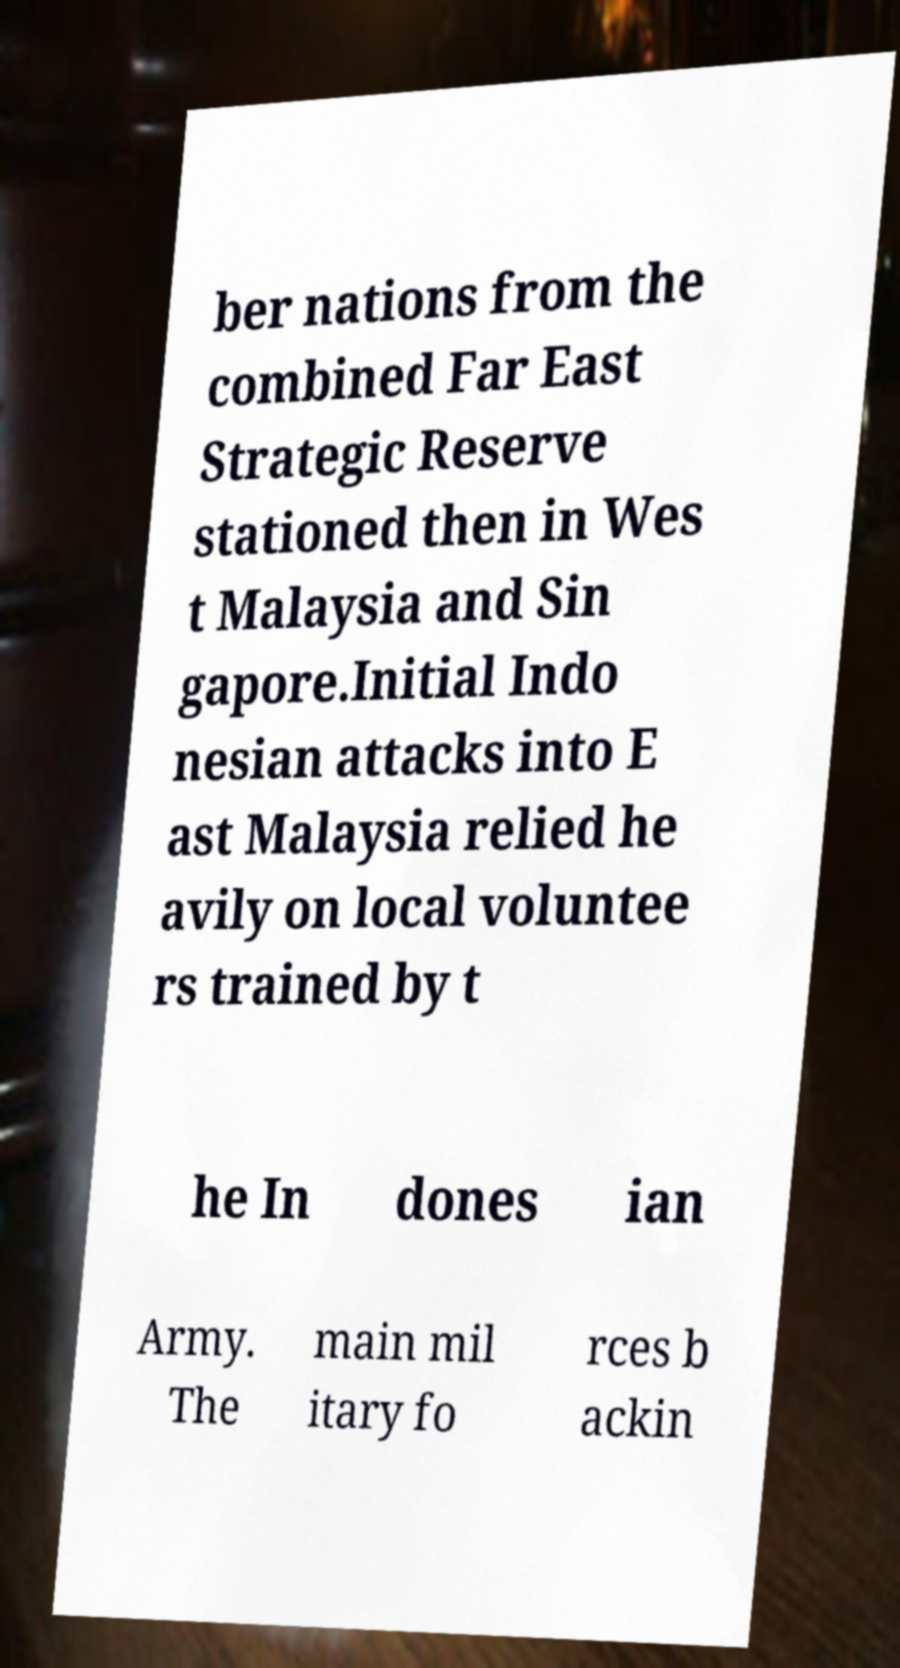For documentation purposes, I need the text within this image transcribed. Could you provide that? ber nations from the combined Far East Strategic Reserve stationed then in Wes t Malaysia and Sin gapore.Initial Indo nesian attacks into E ast Malaysia relied he avily on local voluntee rs trained by t he In dones ian Army. The main mil itary fo rces b ackin 